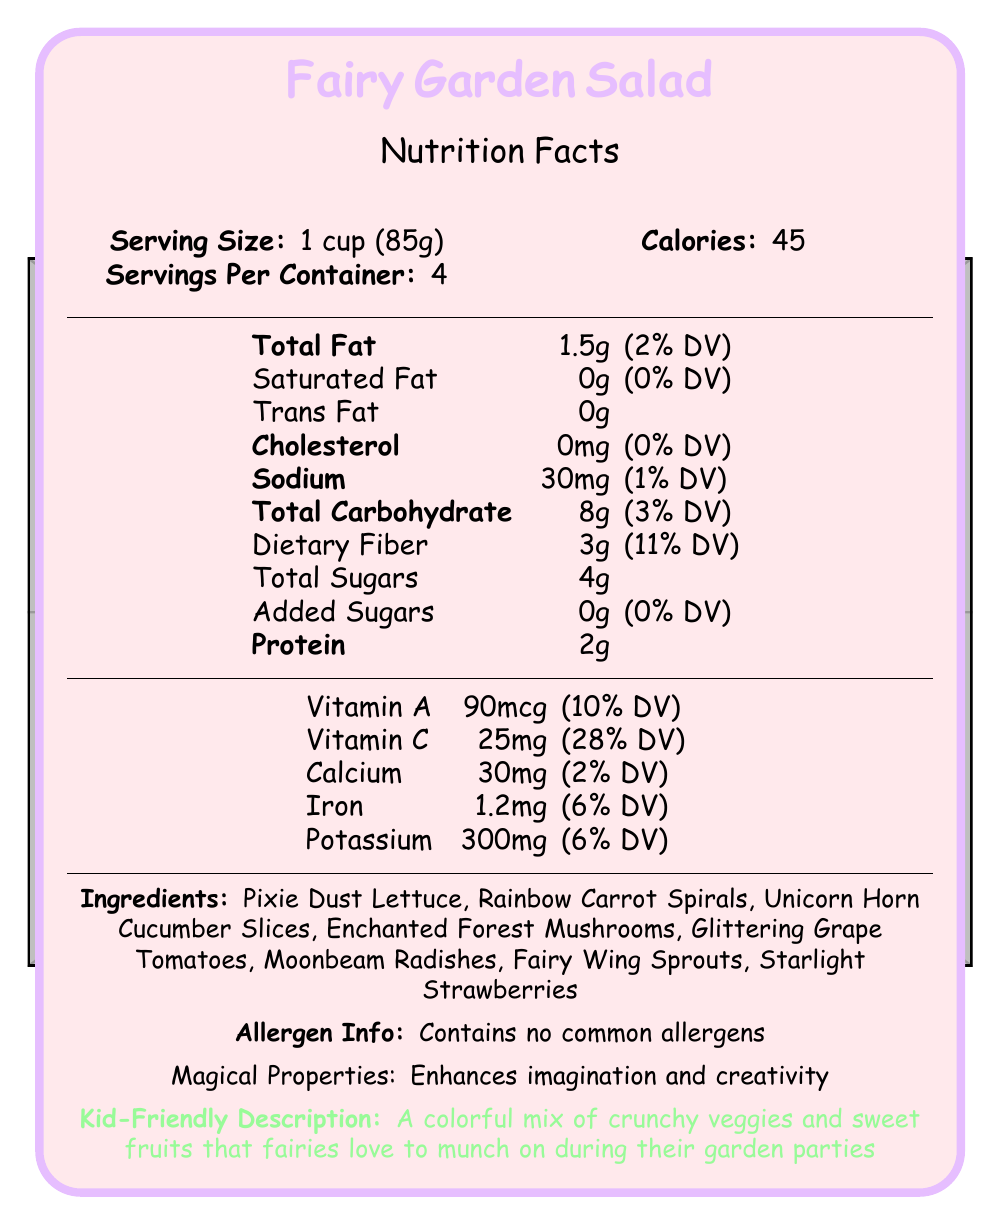what is the serving size of the Fairy Garden Salad? The serving size is listed as "1 cup (85g)" under the "Serving Size" section of the document.
Answer: 1 cup (85g) how many calories are in one serving of the Fairy Garden Salad? The document specifies that each serving contains 45 calories under the "Calories" section.
Answer: 45 how much dietary fiber does the Fairy Garden Salad provide per serving? The document indicates "Dietary Fiber: 3g" under the "Total Carbohydrate" section.
Answer: 3g name two ingredients found in the Fairy Garden Salad. The "Ingredients" section lists "Pixie Dust Lettuce" and "Rainbow Carrot Spirals" among the components.
Answer: Pixie Dust Lettuce, Rainbow Carrot Spirals what is the percentage daily value of vitamin C in one serving? The document lists "Vitamin C 25mg (28% DV)" under the vitamins and minerals section.
Answer: 28% which of the following does the Fairy Garden Salad contain? A. Common allergens B. Gluten C. No common allergens The "Allergen Info" section indicates that the salad "Contains no common allergens."
Answer: C inspired by which storybook is the Fairy Garden Salad? A. The Fairy Book B. The Enchanted Garden C. The Magical Forest The "fairyTaleConnection" mentions that the salad is inspired by "The Enchanted Garden" storybook.
Answer: B does the Fairy Garden Salad have added sugars? The document states "Added Sugars: 0g (0% DV)" under the "Total Carbohydrate" section.
Answer: No how many servings per container are there? The "Serving Size" section mentions that there are 4 servings per container.
Answer: 4 how much potassium does one serving of the Fairy Garden Salad provide? The "Potassium" content is provided as "300mg (6% DV)" under the vitamins and minerals section.
Answer: 300mg summarize the nutritional highlights of the Fairy Garden Salad. The nutritional highlights section emphasizes the beneficial attributes such as excellent vitamin C content, good fiber source, low calorie count, and natural sweetness without added sugars.
Answer: The Fairy Garden Salad is an excellent source of vitamin C, a good source of fiber, low in calories, and contains naturally sweetened fruits with no added sugars. where should I sprinkle edible glitter for extra fairy sparkle? The "servingSuggestions" section advises serving the salad with a sprinkle of edible glitter for extra fairy sparkle.
Answer: On the Fairy Garden Salad how can the Fairy Garden Salad enhance your imagination and creativity? The "storyElements" section states that the salad's magical properties enhance imagination and creativity.
Answer: By containing magical properties how many grams of fat, protein, and carbohydrate are there in one serving respectively? The document lists "Total Fat: 1.5g," "Protein: 2g," and "Total Carbohydrate: 8g" per serving.
Answer: 1.5g fat, 2g protein, 8g carbohydrate can you create a story about how the fairies grow these special vegetables in their garden? The document provides a prompt to create a story but does not provide details on how the fairies grow these vegetables.
Answer: Not enough information 